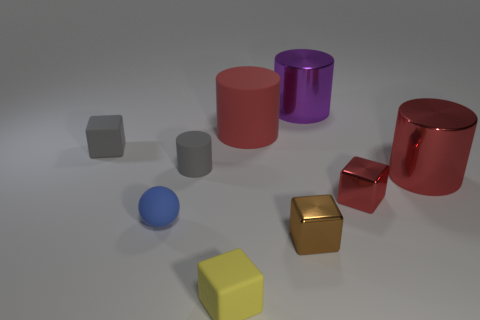Is the big rubber thing the same color as the rubber ball?
Your answer should be very brief. No. What shape is the rubber thing that is behind the tiny rubber object that is to the left of the tiny blue ball?
Ensure brevity in your answer.  Cylinder. What shape is the small blue object that is made of the same material as the tiny yellow object?
Keep it short and to the point. Sphere. What number of other things are there of the same shape as the large rubber thing?
Offer a terse response. 3. Is the size of the matte cube in front of the brown metallic cube the same as the large red rubber cylinder?
Your answer should be compact. No. Is the number of red objects left of the purple metal cylinder greater than the number of large gray rubber objects?
Your response must be concise. Yes. There is a metal cylinder that is to the right of the red cube; what number of yellow rubber blocks are behind it?
Ensure brevity in your answer.  0. Are there fewer blue objects behind the gray cylinder than tiny yellow matte cubes?
Offer a very short reply. Yes. Is there a small brown object that is on the left side of the cube behind the big shiny thing that is right of the big purple object?
Your answer should be compact. No. Is the material of the yellow object the same as the big red cylinder in front of the big rubber cylinder?
Your answer should be compact. No. 